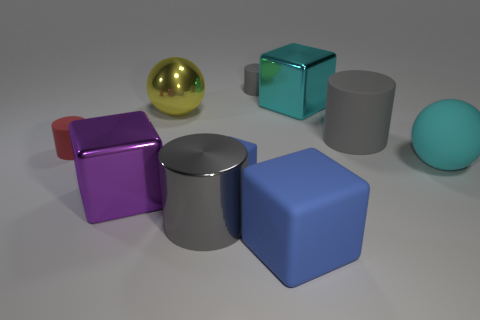The red object that is the same shape as the gray metal object is what size? The red object, which shares the cubic shape with the gray metal object, appears to be of a small size, similar to the size of a standard die or slightly larger. 